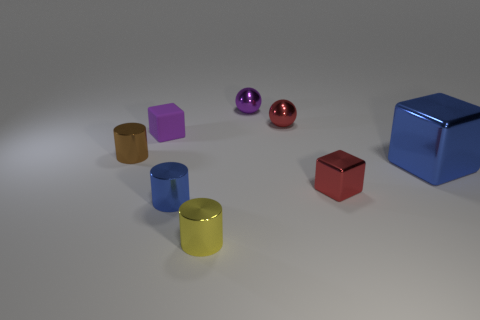Add 1 large cubes. How many objects exist? 9 Subtract all balls. How many objects are left? 6 Subtract all purple spheres. Subtract all small purple matte things. How many objects are left? 6 Add 5 small cylinders. How many small cylinders are left? 8 Add 3 blue metallic things. How many blue metallic things exist? 5 Subtract 0 purple cylinders. How many objects are left? 8 